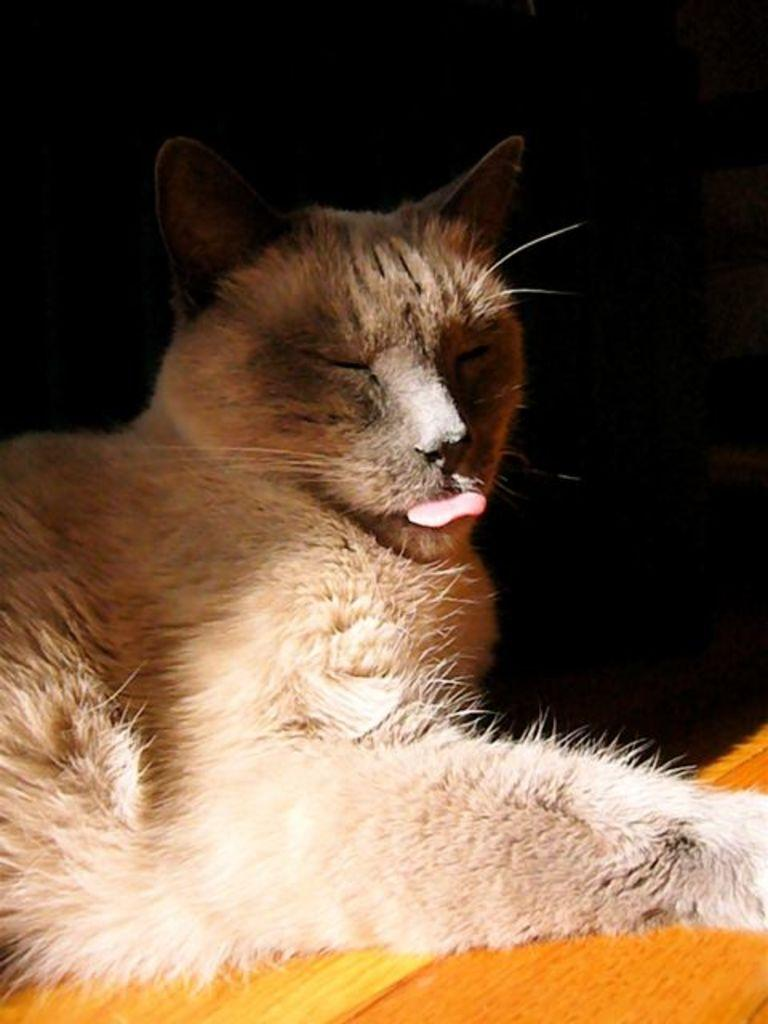What type of creature can be seen in the image? There is an animal in the image. What is the animal doing in the image? The animal is lying on an object. What can be observed about the background of the image? The background of the image is dark. What decision is the animal making in the image? There is no indication in the image that the animal is making a decision. What type of mint can be seen growing in the image? There is no mint present in the image. 